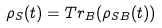<formula> <loc_0><loc_0><loc_500><loc_500>\rho _ { S } ( t ) = T r _ { B } ( \rho _ { S B } ( t ) )</formula> 